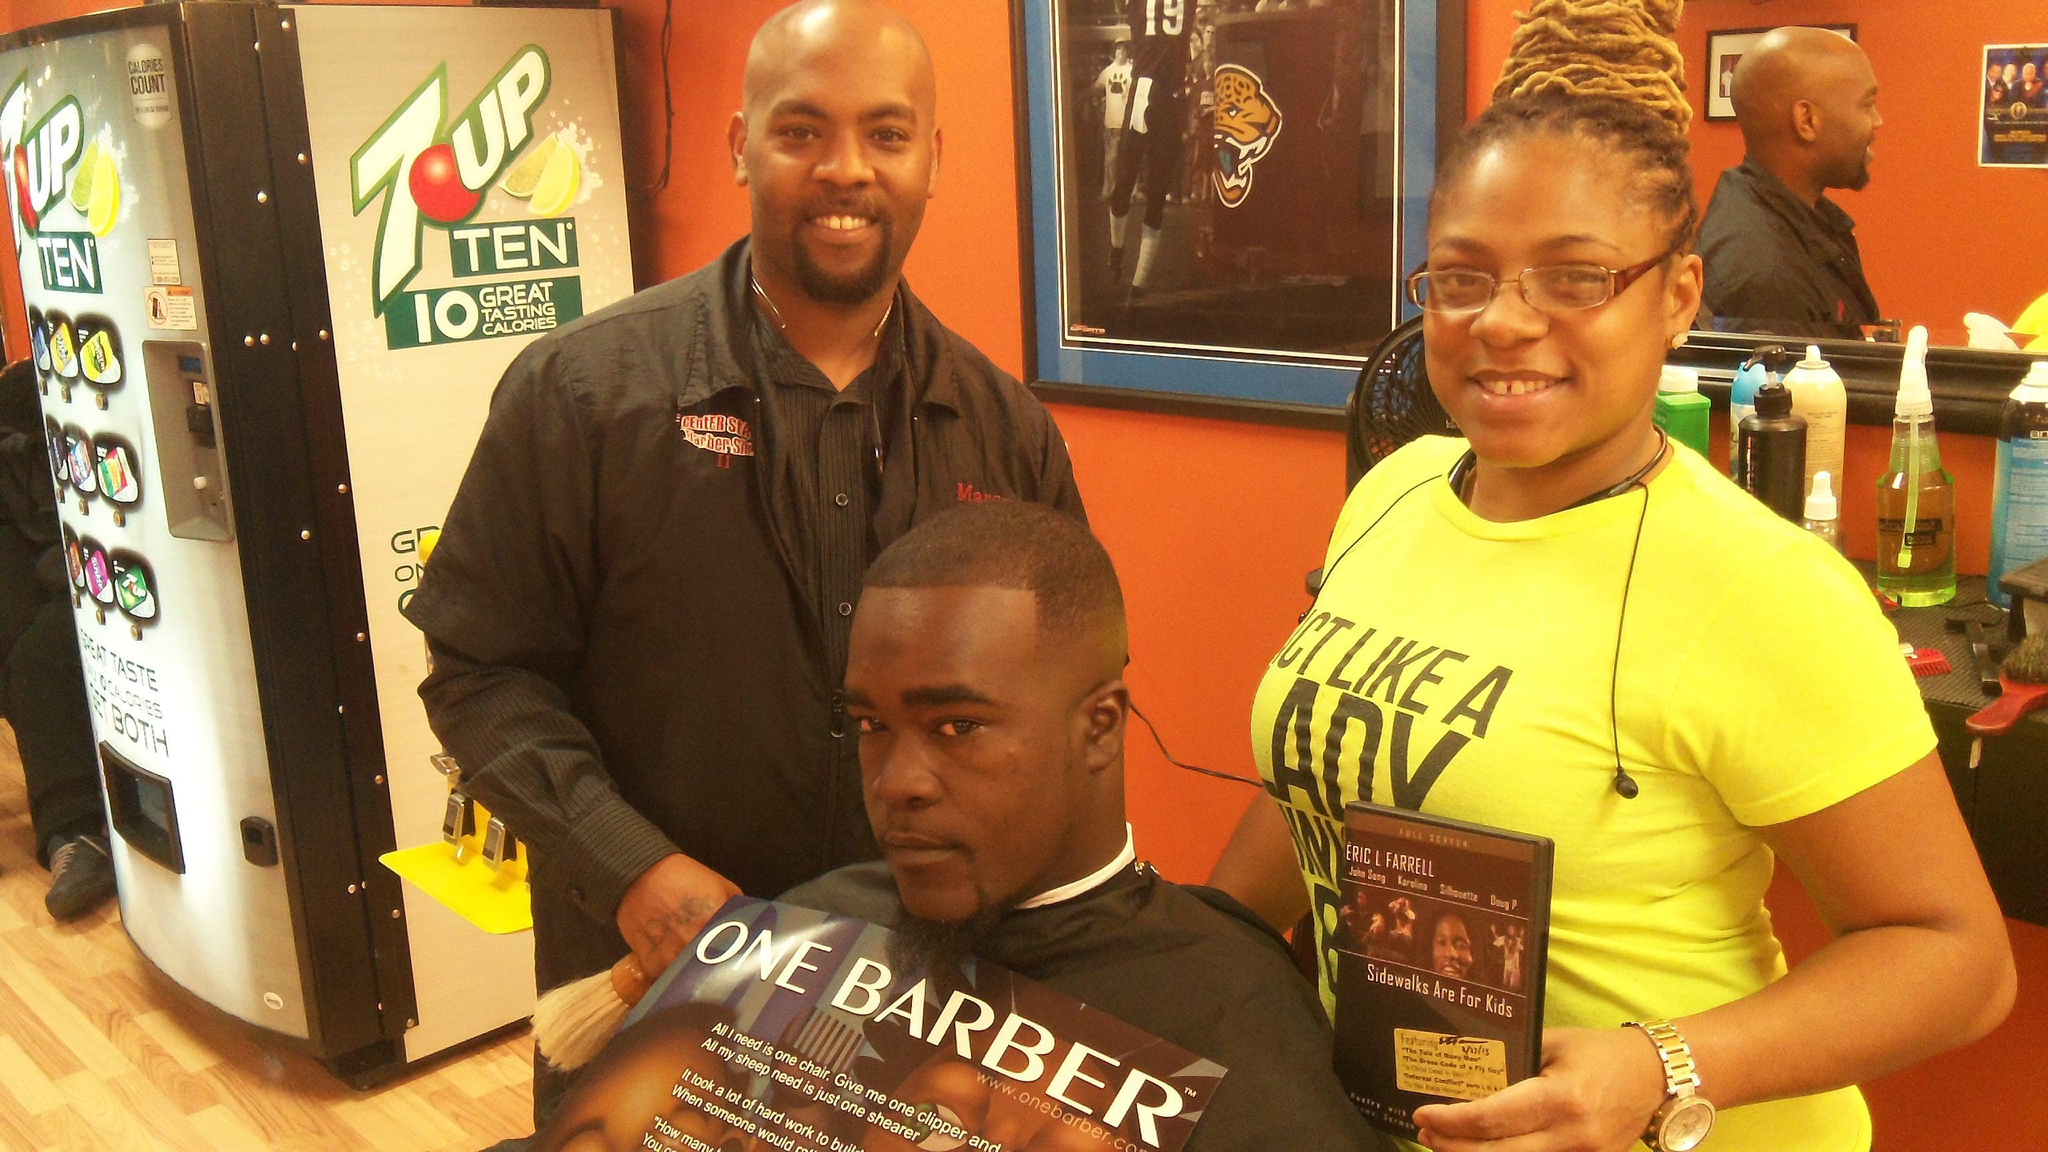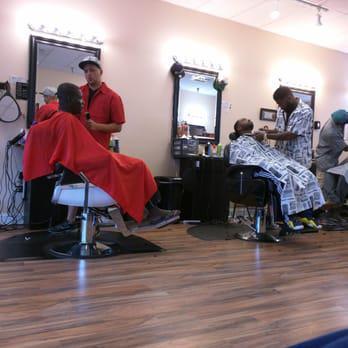The first image is the image on the left, the second image is the image on the right. For the images displayed, is the sentence "You can see there is a TV hanging on the wall in at least one of the images." factually correct? Answer yes or no. No. 